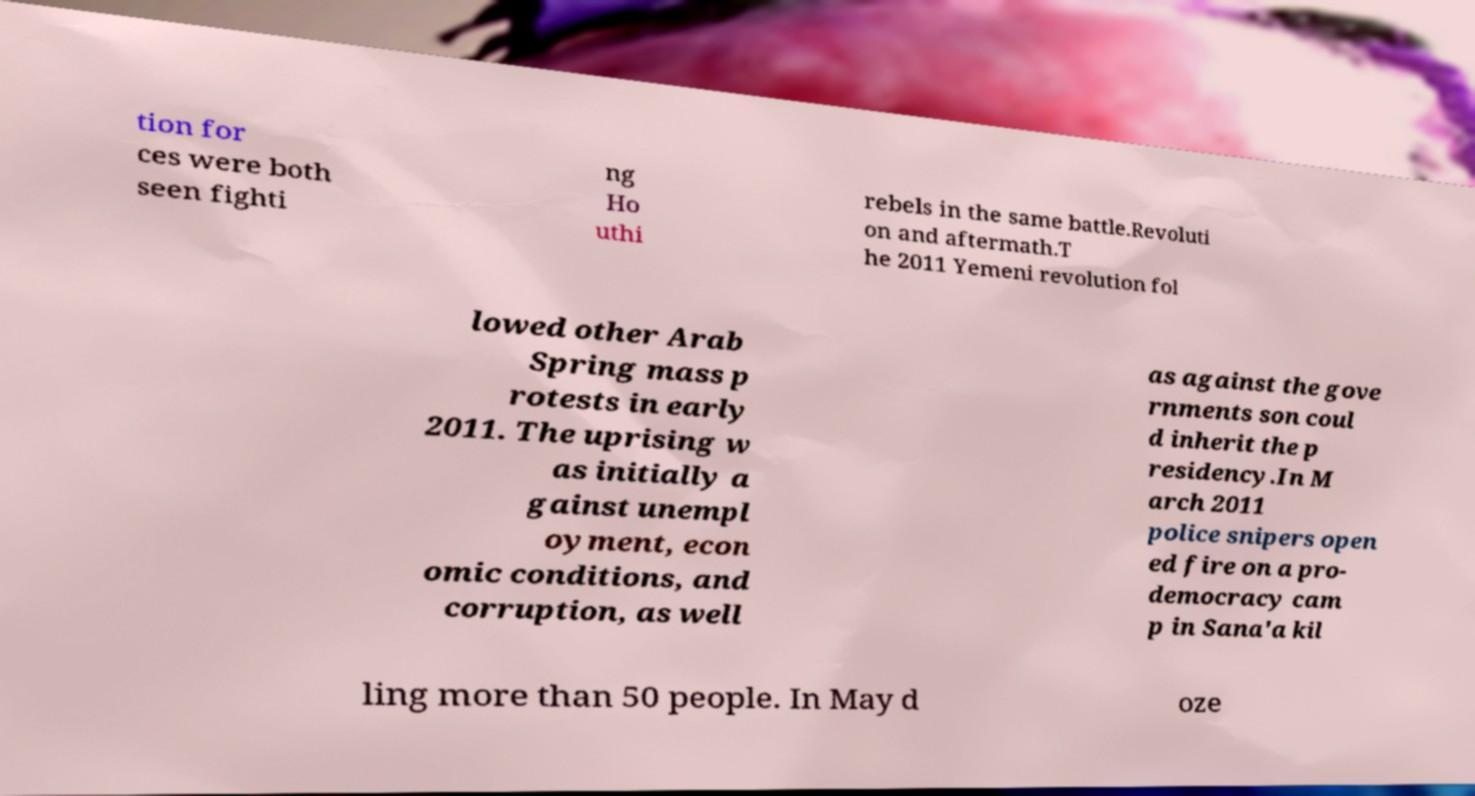For documentation purposes, I need the text within this image transcribed. Could you provide that? tion for ces were both seen fighti ng Ho uthi rebels in the same battle.Revoluti on and aftermath.T he 2011 Yemeni revolution fol lowed other Arab Spring mass p rotests in early 2011. The uprising w as initially a gainst unempl oyment, econ omic conditions, and corruption, as well as against the gove rnments son coul d inherit the p residency.In M arch 2011 police snipers open ed fire on a pro- democracy cam p in Sana'a kil ling more than 50 people. In May d oze 